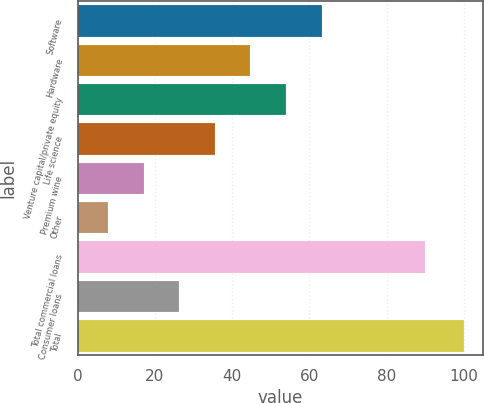<chart> <loc_0><loc_0><loc_500><loc_500><bar_chart><fcel>Software<fcel>Hardware<fcel>Venture capital/private equity<fcel>Life science<fcel>Premium wine<fcel>Other<fcel>Total commercial loans<fcel>Consumer loans<fcel>Total<nl><fcel>63.16<fcel>44.74<fcel>53.95<fcel>35.53<fcel>17.11<fcel>7.9<fcel>90<fcel>26.32<fcel>100<nl></chart> 